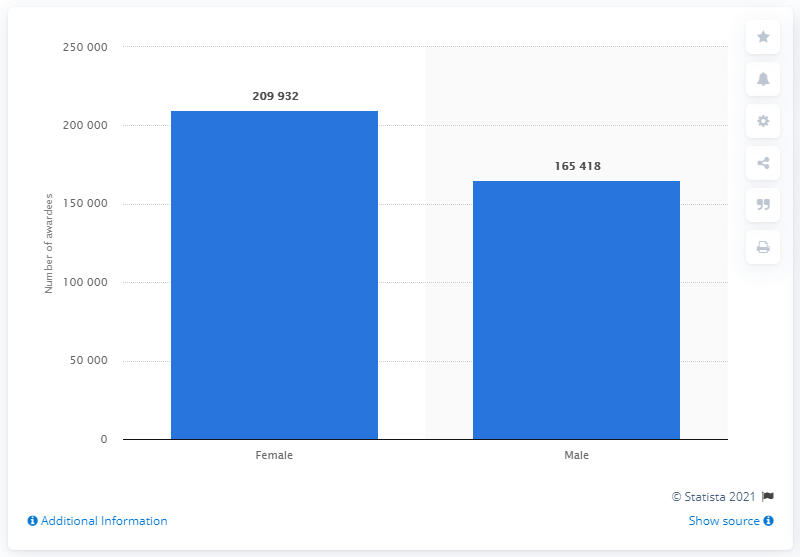Which gender had a higher number of graduates in Karnataka in 2019, and by how much? In 2019, female graduates outnumbered male graduates in Karnataka. There were 209,932 female graduates compared to 165,418 male graduates, making it a difference of 44,514 more female graduates. 